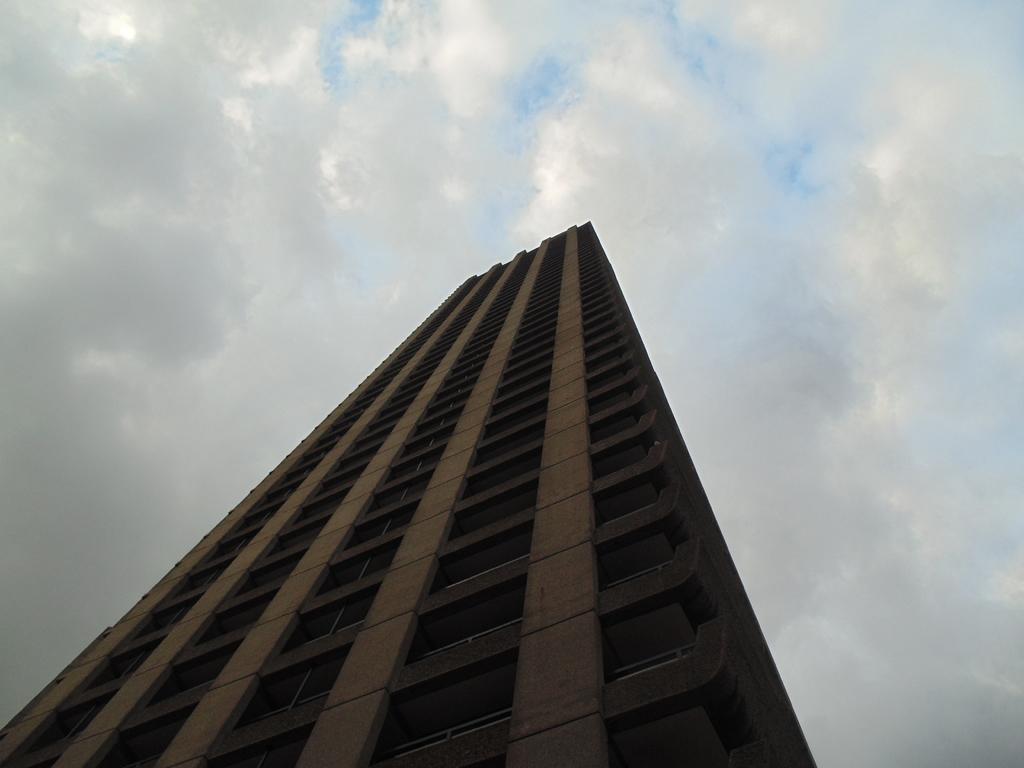Describe this image in one or two sentences. In this image I can see a building which is brown in color and few windows of the building which are black in color. In the background I can see the sky. 